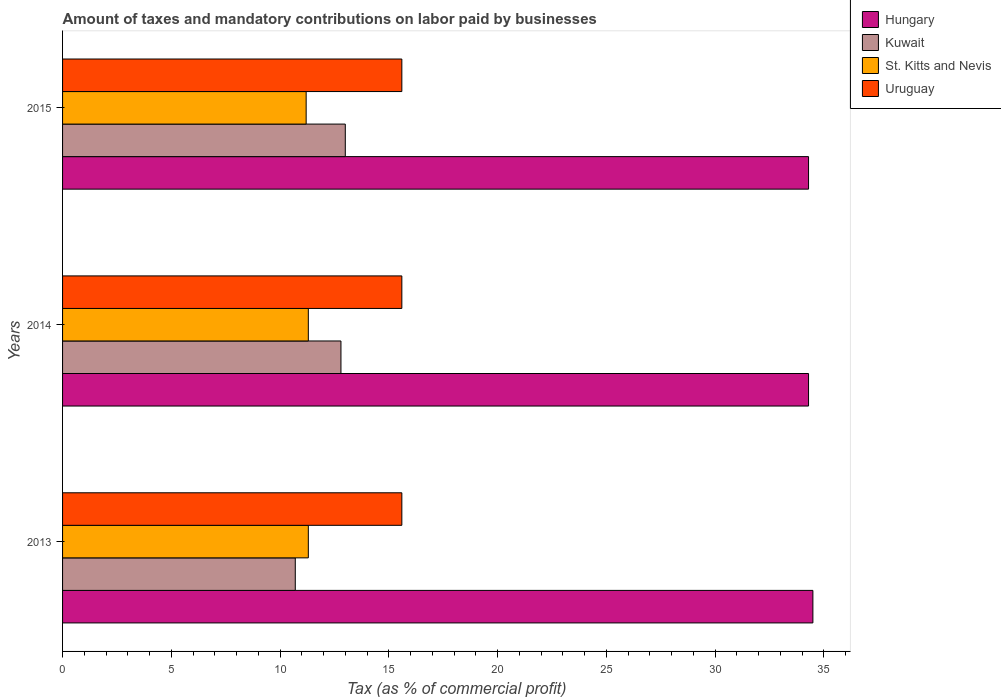Are the number of bars per tick equal to the number of legend labels?
Your answer should be very brief. Yes. Are the number of bars on each tick of the Y-axis equal?
Provide a short and direct response. Yes. How many bars are there on the 1st tick from the top?
Offer a terse response. 4. How many bars are there on the 3rd tick from the bottom?
Keep it short and to the point. 4. What is the label of the 3rd group of bars from the top?
Your answer should be compact. 2013. What is the percentage of taxes paid by businesses in Hungary in 2013?
Keep it short and to the point. 34.5. Across all years, what is the maximum percentage of taxes paid by businesses in Uruguay?
Provide a succinct answer. 15.6. In which year was the percentage of taxes paid by businesses in St. Kitts and Nevis minimum?
Provide a short and direct response. 2015. What is the total percentage of taxes paid by businesses in St. Kitts and Nevis in the graph?
Provide a short and direct response. 33.8. What is the difference between the percentage of taxes paid by businesses in St. Kitts and Nevis in 2013 and the percentage of taxes paid by businesses in Uruguay in 2015?
Give a very brief answer. -4.3. In the year 2015, what is the difference between the percentage of taxes paid by businesses in Kuwait and percentage of taxes paid by businesses in Uruguay?
Provide a short and direct response. -2.6. What is the ratio of the percentage of taxes paid by businesses in Kuwait in 2013 to that in 2015?
Offer a terse response. 0.82. Is the percentage of taxes paid by businesses in Uruguay in 2014 less than that in 2015?
Give a very brief answer. No. Is the difference between the percentage of taxes paid by businesses in Kuwait in 2014 and 2015 greater than the difference between the percentage of taxes paid by businesses in Uruguay in 2014 and 2015?
Your response must be concise. No. What is the difference between the highest and the second highest percentage of taxes paid by businesses in Uruguay?
Make the answer very short. 0. What is the difference between the highest and the lowest percentage of taxes paid by businesses in Kuwait?
Make the answer very short. 2.3. In how many years, is the percentage of taxes paid by businesses in Hungary greater than the average percentage of taxes paid by businesses in Hungary taken over all years?
Your answer should be very brief. 1. Is the sum of the percentage of taxes paid by businesses in Uruguay in 2013 and 2014 greater than the maximum percentage of taxes paid by businesses in Hungary across all years?
Your answer should be very brief. No. What does the 4th bar from the top in 2015 represents?
Keep it short and to the point. Hungary. What does the 2nd bar from the bottom in 2013 represents?
Provide a succinct answer. Kuwait. Is it the case that in every year, the sum of the percentage of taxes paid by businesses in Hungary and percentage of taxes paid by businesses in Kuwait is greater than the percentage of taxes paid by businesses in Uruguay?
Your answer should be compact. Yes. How many bars are there?
Offer a very short reply. 12. Are all the bars in the graph horizontal?
Ensure brevity in your answer.  Yes. How many years are there in the graph?
Provide a short and direct response. 3. Are the values on the major ticks of X-axis written in scientific E-notation?
Keep it short and to the point. No. Does the graph contain any zero values?
Offer a terse response. No. Where does the legend appear in the graph?
Provide a short and direct response. Top right. How are the legend labels stacked?
Ensure brevity in your answer.  Vertical. What is the title of the graph?
Your response must be concise. Amount of taxes and mandatory contributions on labor paid by businesses. What is the label or title of the X-axis?
Provide a succinct answer. Tax (as % of commercial profit). What is the Tax (as % of commercial profit) in Hungary in 2013?
Offer a terse response. 34.5. What is the Tax (as % of commercial profit) in Kuwait in 2013?
Make the answer very short. 10.7. What is the Tax (as % of commercial profit) in St. Kitts and Nevis in 2013?
Your response must be concise. 11.3. What is the Tax (as % of commercial profit) of Uruguay in 2013?
Keep it short and to the point. 15.6. What is the Tax (as % of commercial profit) of Hungary in 2014?
Your answer should be very brief. 34.3. What is the Tax (as % of commercial profit) in Uruguay in 2014?
Your answer should be very brief. 15.6. What is the Tax (as % of commercial profit) of Hungary in 2015?
Your answer should be very brief. 34.3. What is the Tax (as % of commercial profit) of St. Kitts and Nevis in 2015?
Give a very brief answer. 11.2. What is the Tax (as % of commercial profit) in Uruguay in 2015?
Provide a short and direct response. 15.6. Across all years, what is the maximum Tax (as % of commercial profit) in Hungary?
Keep it short and to the point. 34.5. Across all years, what is the maximum Tax (as % of commercial profit) of Kuwait?
Provide a succinct answer. 13. Across all years, what is the maximum Tax (as % of commercial profit) of St. Kitts and Nevis?
Offer a terse response. 11.3. Across all years, what is the minimum Tax (as % of commercial profit) of Hungary?
Offer a very short reply. 34.3. Across all years, what is the minimum Tax (as % of commercial profit) of St. Kitts and Nevis?
Give a very brief answer. 11.2. What is the total Tax (as % of commercial profit) of Hungary in the graph?
Make the answer very short. 103.1. What is the total Tax (as % of commercial profit) of Kuwait in the graph?
Your answer should be compact. 36.5. What is the total Tax (as % of commercial profit) in St. Kitts and Nevis in the graph?
Provide a short and direct response. 33.8. What is the total Tax (as % of commercial profit) in Uruguay in the graph?
Provide a short and direct response. 46.8. What is the difference between the Tax (as % of commercial profit) of Hungary in 2013 and that in 2014?
Your answer should be compact. 0.2. What is the difference between the Tax (as % of commercial profit) of Kuwait in 2013 and that in 2014?
Your answer should be very brief. -2.1. What is the difference between the Tax (as % of commercial profit) of Uruguay in 2013 and that in 2014?
Your answer should be very brief. 0. What is the difference between the Tax (as % of commercial profit) of Hungary in 2013 and that in 2015?
Provide a short and direct response. 0.2. What is the difference between the Tax (as % of commercial profit) of St. Kitts and Nevis in 2013 and that in 2015?
Offer a terse response. 0.1. What is the difference between the Tax (as % of commercial profit) in Hungary in 2013 and the Tax (as % of commercial profit) in Kuwait in 2014?
Provide a short and direct response. 21.7. What is the difference between the Tax (as % of commercial profit) in Hungary in 2013 and the Tax (as % of commercial profit) in St. Kitts and Nevis in 2014?
Give a very brief answer. 23.2. What is the difference between the Tax (as % of commercial profit) in Kuwait in 2013 and the Tax (as % of commercial profit) in Uruguay in 2014?
Make the answer very short. -4.9. What is the difference between the Tax (as % of commercial profit) in St. Kitts and Nevis in 2013 and the Tax (as % of commercial profit) in Uruguay in 2014?
Make the answer very short. -4.3. What is the difference between the Tax (as % of commercial profit) in Hungary in 2013 and the Tax (as % of commercial profit) in St. Kitts and Nevis in 2015?
Your answer should be very brief. 23.3. What is the difference between the Tax (as % of commercial profit) in Kuwait in 2013 and the Tax (as % of commercial profit) in St. Kitts and Nevis in 2015?
Your answer should be compact. -0.5. What is the difference between the Tax (as % of commercial profit) of Kuwait in 2013 and the Tax (as % of commercial profit) of Uruguay in 2015?
Provide a succinct answer. -4.9. What is the difference between the Tax (as % of commercial profit) in Hungary in 2014 and the Tax (as % of commercial profit) in Kuwait in 2015?
Ensure brevity in your answer.  21.3. What is the difference between the Tax (as % of commercial profit) of Hungary in 2014 and the Tax (as % of commercial profit) of St. Kitts and Nevis in 2015?
Your response must be concise. 23.1. What is the difference between the Tax (as % of commercial profit) of Hungary in 2014 and the Tax (as % of commercial profit) of Uruguay in 2015?
Offer a very short reply. 18.7. What is the difference between the Tax (as % of commercial profit) of Kuwait in 2014 and the Tax (as % of commercial profit) of Uruguay in 2015?
Keep it short and to the point. -2.8. What is the difference between the Tax (as % of commercial profit) of St. Kitts and Nevis in 2014 and the Tax (as % of commercial profit) of Uruguay in 2015?
Your response must be concise. -4.3. What is the average Tax (as % of commercial profit) of Hungary per year?
Keep it short and to the point. 34.37. What is the average Tax (as % of commercial profit) in Kuwait per year?
Your answer should be compact. 12.17. What is the average Tax (as % of commercial profit) of St. Kitts and Nevis per year?
Make the answer very short. 11.27. In the year 2013, what is the difference between the Tax (as % of commercial profit) of Hungary and Tax (as % of commercial profit) of Kuwait?
Your answer should be compact. 23.8. In the year 2013, what is the difference between the Tax (as % of commercial profit) in Hungary and Tax (as % of commercial profit) in St. Kitts and Nevis?
Provide a short and direct response. 23.2. In the year 2013, what is the difference between the Tax (as % of commercial profit) of Hungary and Tax (as % of commercial profit) of Uruguay?
Offer a terse response. 18.9. In the year 2013, what is the difference between the Tax (as % of commercial profit) in Kuwait and Tax (as % of commercial profit) in St. Kitts and Nevis?
Make the answer very short. -0.6. In the year 2013, what is the difference between the Tax (as % of commercial profit) in St. Kitts and Nevis and Tax (as % of commercial profit) in Uruguay?
Ensure brevity in your answer.  -4.3. In the year 2014, what is the difference between the Tax (as % of commercial profit) of Hungary and Tax (as % of commercial profit) of Kuwait?
Offer a very short reply. 21.5. In the year 2014, what is the difference between the Tax (as % of commercial profit) in Hungary and Tax (as % of commercial profit) in St. Kitts and Nevis?
Offer a terse response. 23. In the year 2014, what is the difference between the Tax (as % of commercial profit) of Hungary and Tax (as % of commercial profit) of Uruguay?
Make the answer very short. 18.7. In the year 2015, what is the difference between the Tax (as % of commercial profit) of Hungary and Tax (as % of commercial profit) of Kuwait?
Give a very brief answer. 21.3. In the year 2015, what is the difference between the Tax (as % of commercial profit) of Hungary and Tax (as % of commercial profit) of St. Kitts and Nevis?
Keep it short and to the point. 23.1. In the year 2015, what is the difference between the Tax (as % of commercial profit) of Hungary and Tax (as % of commercial profit) of Uruguay?
Keep it short and to the point. 18.7. What is the ratio of the Tax (as % of commercial profit) in Kuwait in 2013 to that in 2014?
Your response must be concise. 0.84. What is the ratio of the Tax (as % of commercial profit) in St. Kitts and Nevis in 2013 to that in 2014?
Keep it short and to the point. 1. What is the ratio of the Tax (as % of commercial profit) of Hungary in 2013 to that in 2015?
Provide a short and direct response. 1.01. What is the ratio of the Tax (as % of commercial profit) of Kuwait in 2013 to that in 2015?
Offer a very short reply. 0.82. What is the ratio of the Tax (as % of commercial profit) in St. Kitts and Nevis in 2013 to that in 2015?
Offer a very short reply. 1.01. What is the ratio of the Tax (as % of commercial profit) in Kuwait in 2014 to that in 2015?
Provide a short and direct response. 0.98. What is the ratio of the Tax (as % of commercial profit) in St. Kitts and Nevis in 2014 to that in 2015?
Give a very brief answer. 1.01. What is the difference between the highest and the second highest Tax (as % of commercial profit) of Hungary?
Your response must be concise. 0.2. What is the difference between the highest and the second highest Tax (as % of commercial profit) in Uruguay?
Your answer should be compact. 0. What is the difference between the highest and the lowest Tax (as % of commercial profit) in Hungary?
Your response must be concise. 0.2. What is the difference between the highest and the lowest Tax (as % of commercial profit) of Kuwait?
Offer a terse response. 2.3. What is the difference between the highest and the lowest Tax (as % of commercial profit) in St. Kitts and Nevis?
Provide a succinct answer. 0.1. What is the difference between the highest and the lowest Tax (as % of commercial profit) of Uruguay?
Your response must be concise. 0. 